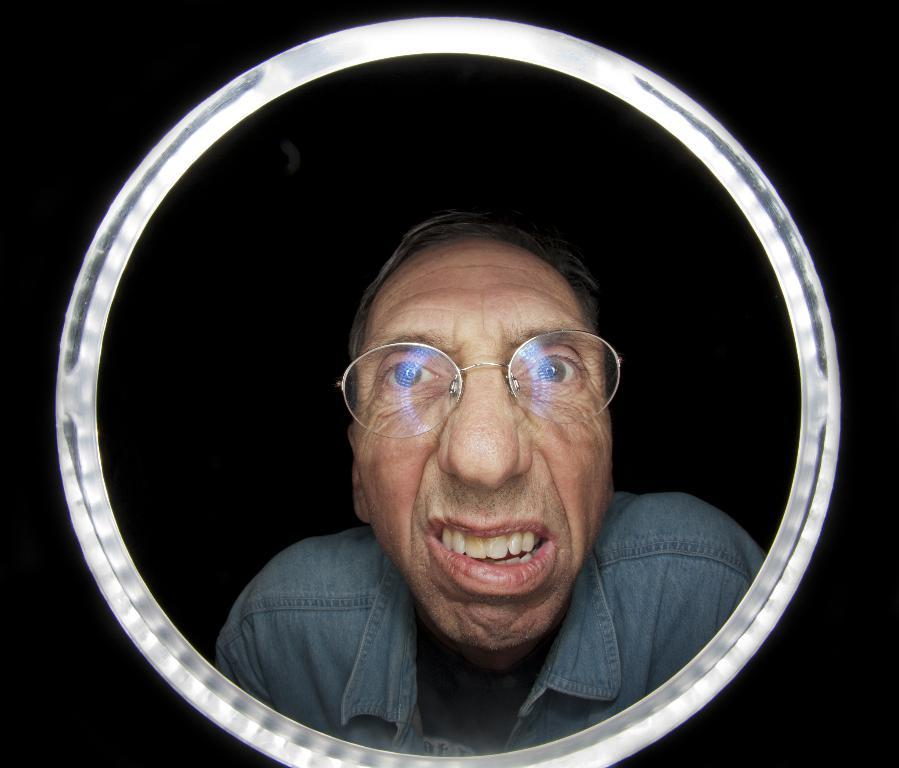What can be seen in the image that is not the actual person? There is a reflection of a person in the image. Where is the reflection located? The reflection is in a mirror. What is the condition of the background in the image? The background of the image is blurred. Can you see a zephyr blowing the person's hair in the image? There is no zephyr present in the image. Is there a bottle visible in the image? There is no bottle present in the image. 